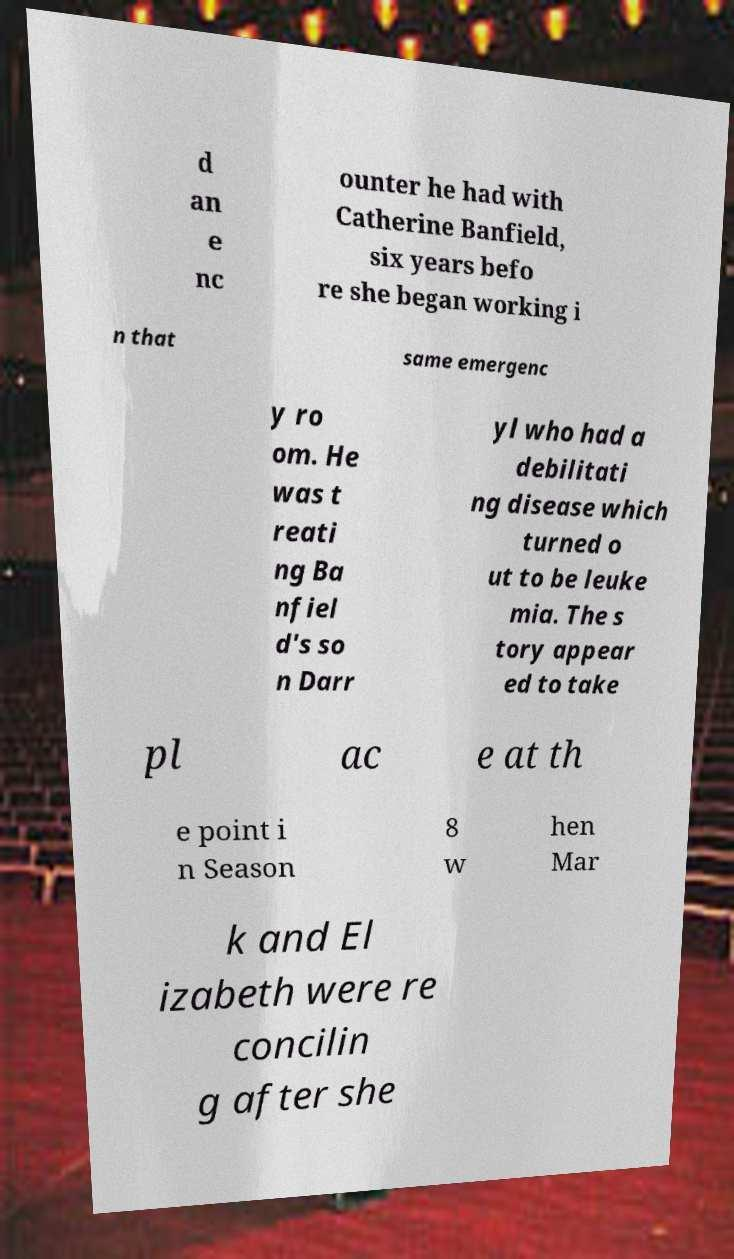What messages or text are displayed in this image? I need them in a readable, typed format. d an e nc ounter he had with Catherine Banfield, six years befo re she began working i n that same emergenc y ro om. He was t reati ng Ba nfiel d's so n Darr yl who had a debilitati ng disease which turned o ut to be leuke mia. The s tory appear ed to take pl ac e at th e point i n Season 8 w hen Mar k and El izabeth were re concilin g after she 